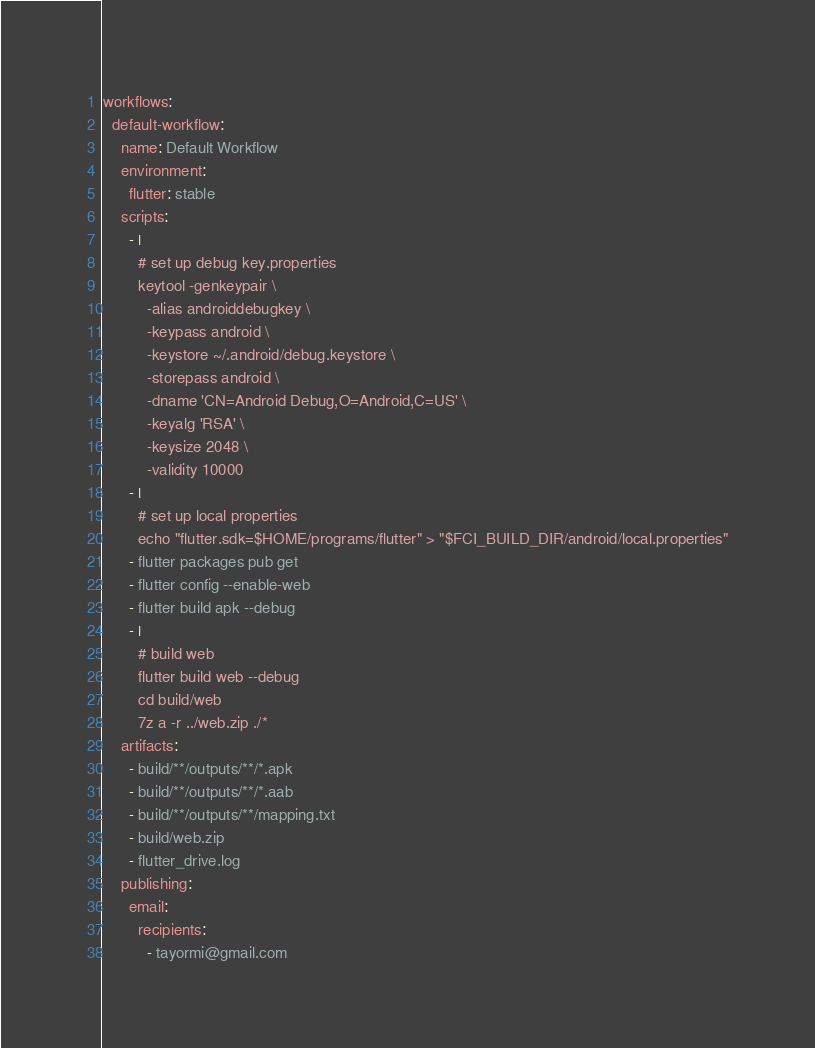<code> <loc_0><loc_0><loc_500><loc_500><_YAML_>workflows:
  default-workflow:
    name: Default Workflow
    environment:
      flutter: stable
    scripts:
      - |
        # set up debug key.properties
        keytool -genkeypair \
          -alias androiddebugkey \
          -keypass android \
          -keystore ~/.android/debug.keystore \
          -storepass android \
          -dname 'CN=Android Debug,O=Android,C=US' \
          -keyalg 'RSA' \
          -keysize 2048 \
          -validity 10000
      - |
        # set up local properties
        echo "flutter.sdk=$HOME/programs/flutter" > "$FCI_BUILD_DIR/android/local.properties"
      - flutter packages pub get
      - flutter config --enable-web
      - flutter build apk --debug
      - |
        # build web
        flutter build web --debug
        cd build/web
        7z a -r ../web.zip ./*
    artifacts:
      - build/**/outputs/**/*.apk
      - build/**/outputs/**/*.aab
      - build/**/outputs/**/mapping.txt
      - build/web.zip
      - flutter_drive.log
    publishing:
      email:
        recipients:
          - tayormi@gmail.com
</code> 